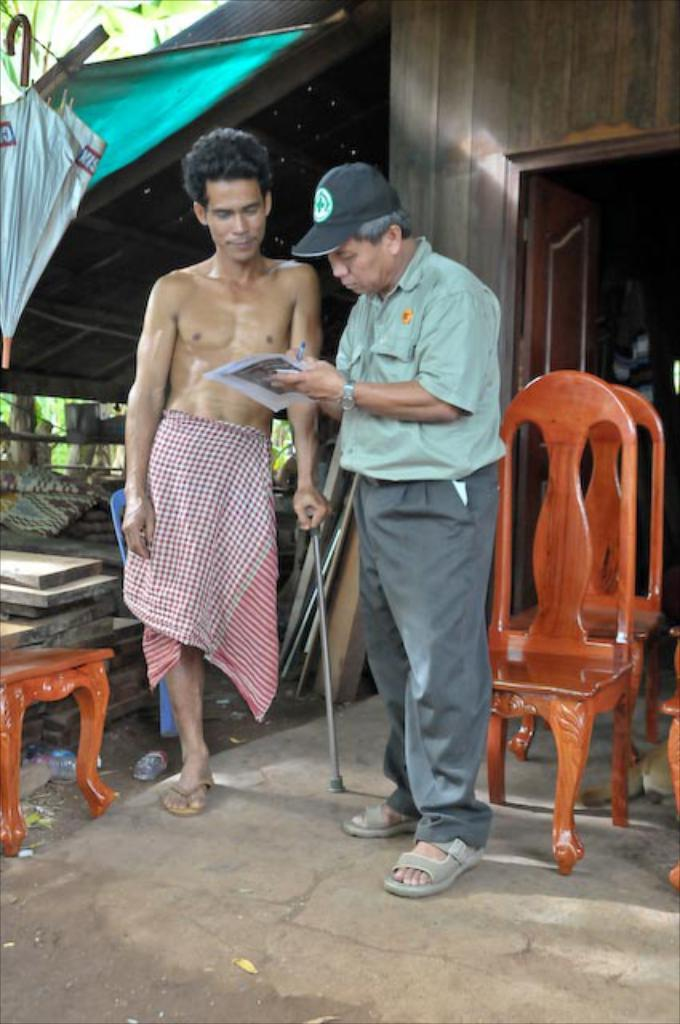How many people are in the image? There are people in the image, but the exact number is not specified. What are the people doing in the image? The people are standing in the image. What is the opinion of the dirt on the tail in the image? There is no dirt or tail present in the image, so it is not possible to determine an opinion about them. 